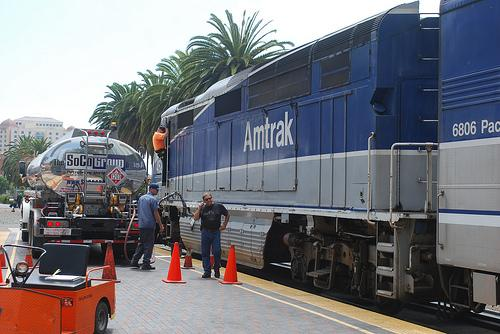What are five different ways to describe the main object in the image? 5. Blue and gray passenger train. What type of vehicle is parked near the train and what is its purpose? A gas tanker is parked near the train, which might be used for fueling purposes. Explain the role of cones in the given image. The cones might be used for safety or signaling purposes, possibly indicating a restricted area around the train or maintenance work. What can you infer about the man mentioned in the image? The man is wearing a blue shirt, blue jeans, possibly climbing on the train, and may have an orange shirt on as well. List three things happening around the train in the image. 3. Orange cones are placed on the ground. What is happening with the weather in the image? There are white clouds in the blue sky, implying a partly cloudy day. What does the image imply about the situation with the train? It suggests that the train is parked at a station or in the city, taking on passengers, and possibly being repaired or fixed. 